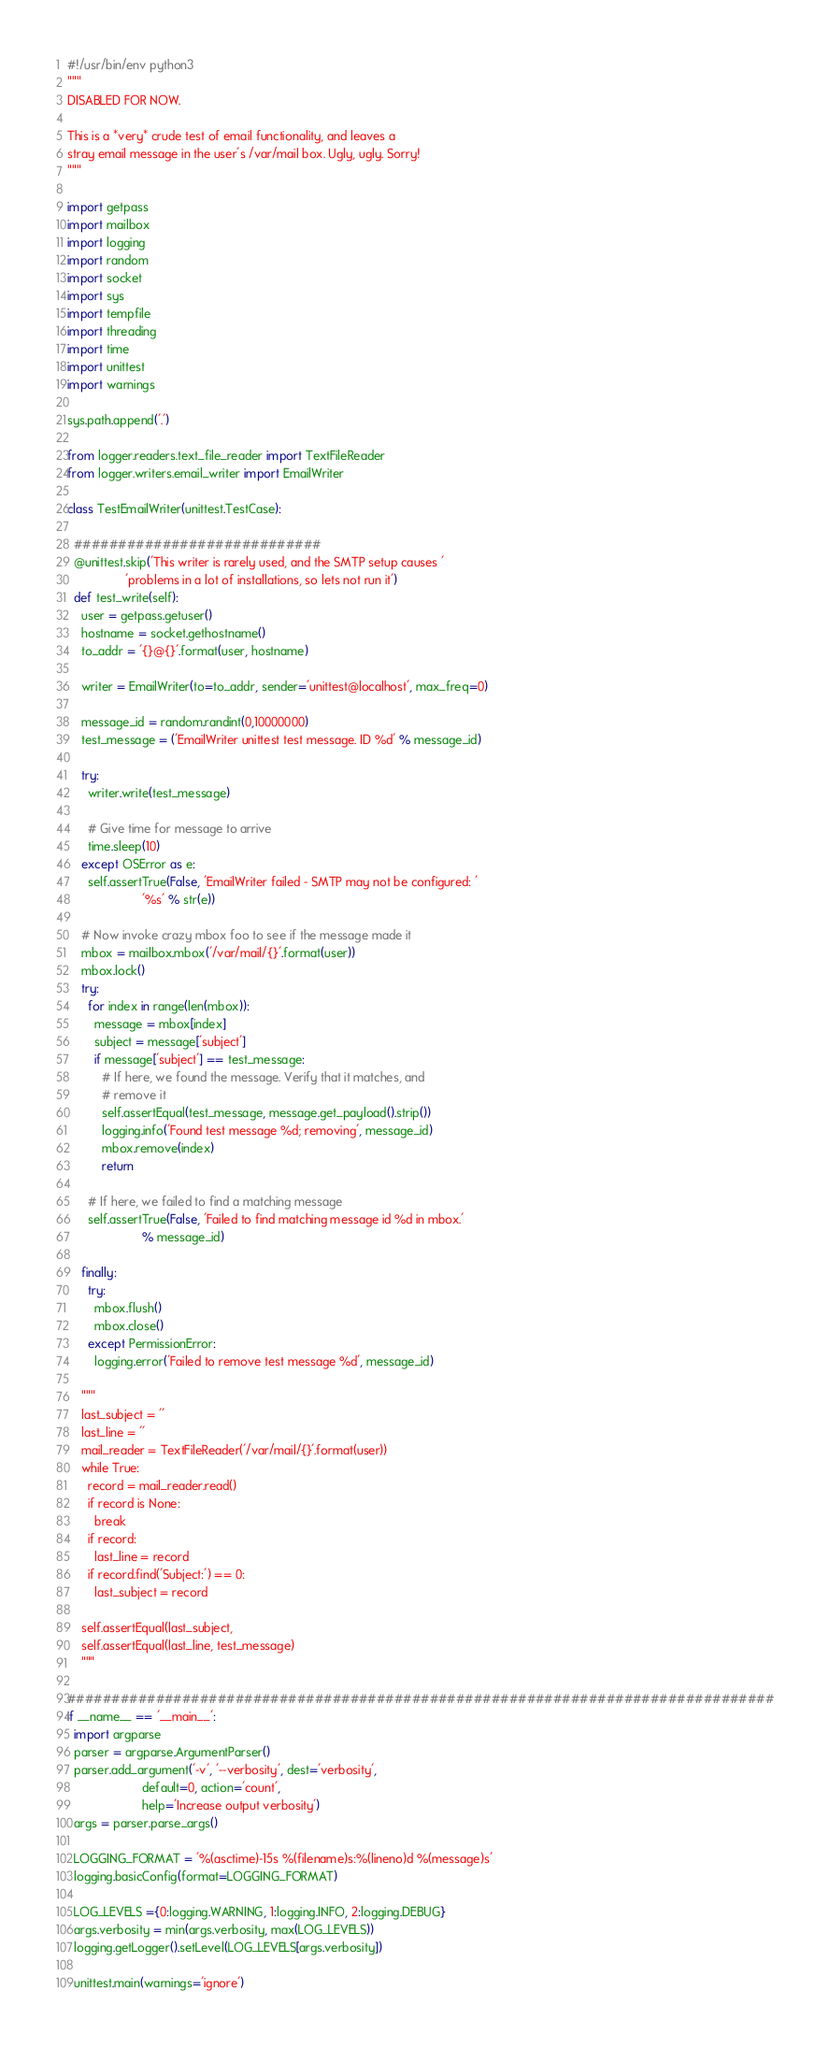Convert code to text. <code><loc_0><loc_0><loc_500><loc_500><_Python_>#!/usr/bin/env python3
"""
DISABLED FOR NOW.

This is a *very* crude test of email functionality, and leaves a
stray email message in the user's /var/mail box. Ugly, ugly. Sorry!
"""

import getpass
import mailbox
import logging
import random
import socket
import sys
import tempfile
import threading
import time
import unittest
import warnings

sys.path.append('.')

from logger.readers.text_file_reader import TextFileReader
from logger.writers.email_writer import EmailWriter

class TestEmailWriter(unittest.TestCase):

  ############################
  @unittest.skip('This writer is rarely used, and the SMTP setup causes '
                 'problems in a lot of installations, so lets not run it')
  def test_write(self):
    user = getpass.getuser()
    hostname = socket.gethostname()
    to_addr = '{}@{}'.format(user, hostname)
    
    writer = EmailWriter(to=to_addr, sender='unittest@localhost', max_freq=0)

    message_id = random.randint(0,10000000)
    test_message = ('EmailWriter unittest test message. ID %d' % message_id)

    try:
      writer.write(test_message)

      # Give time for message to arrive
      time.sleep(10)
    except OSError as e:
      self.assertTrue(False, 'EmailWriter failed - SMTP may not be configured: '
                      '%s' % str(e))
      
    # Now invoke crazy mbox foo to see if the message made it
    mbox = mailbox.mbox('/var/mail/{}'.format(user))
    mbox.lock()
    try:
      for index in range(len(mbox)):
        message = mbox[index]
        subject = message['subject']
        if message['subject'] == test_message:
          # If here, we found the message. Verify that it matches, and
          # remove it
          self.assertEqual(test_message, message.get_payload().strip())
          logging.info('Found test message %d; removing', message_id)
          mbox.remove(index)
          return

      # If here, we failed to find a matching message
      self.assertTrue(False, 'Failed to find matching message id %d in mbox.'
                      % message_id)
      
    finally:
      try:
        mbox.flush()
        mbox.close()
      except PermissionError:
        logging.error('Failed to remove test message %d', message_id)
        
    """
    last_subject = ''
    last_line = ''
    mail_reader = TextFileReader('/var/mail/{}'.format(user))
    while True:
      record = mail_reader.read()
      if record is None:
        break
      if record:
        last_line = record
      if record.find('Subject:') == 0:
        last_subject = record

    self.assertEqual(last_subject, 
    self.assertEqual(last_line, test_message)
    """
    
################################################################################
if __name__ == '__main__':
  import argparse
  parser = argparse.ArgumentParser()
  parser.add_argument('-v', '--verbosity', dest='verbosity',
                      default=0, action='count',
                      help='Increase output verbosity')
  args = parser.parse_args()

  LOGGING_FORMAT = '%(asctime)-15s %(filename)s:%(lineno)d %(message)s'
  logging.basicConfig(format=LOGGING_FORMAT)

  LOG_LEVELS ={0:logging.WARNING, 1:logging.INFO, 2:logging.DEBUG}
  args.verbosity = min(args.verbosity, max(LOG_LEVELS))
  logging.getLogger().setLevel(LOG_LEVELS[args.verbosity])
  
  unittest.main(warnings='ignore')
</code> 